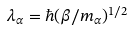<formula> <loc_0><loc_0><loc_500><loc_500>\lambda _ { \alpha } = \hbar { ( } \beta / m _ { \alpha } ) ^ { 1 / 2 }</formula> 